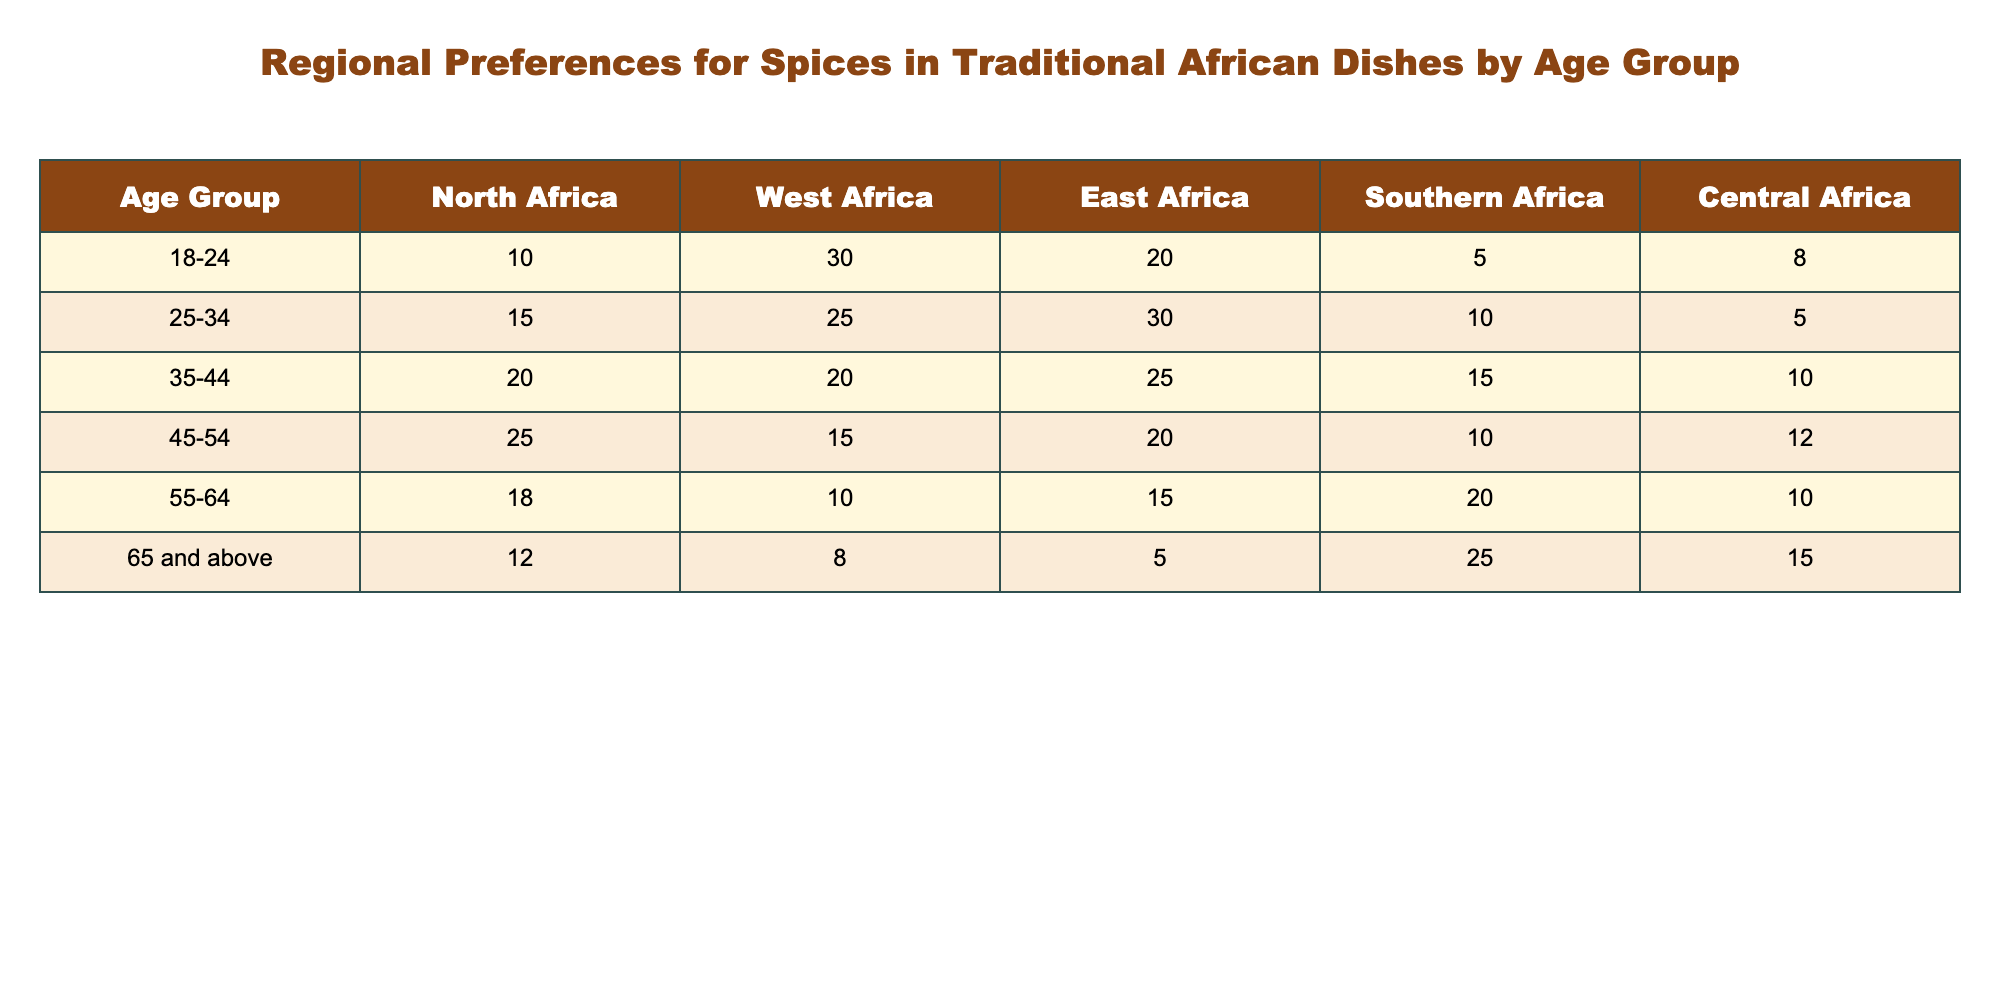What is the highest number of spice preferences in East Africa for any age group? The age group with the highest number of spice preferences in East Africa is 25-34, which shows a preference of 30. Looking at the column for East Africa, I see the following values: 20, 30, 25, 20, 15, and 5. The maximum is clearly 30.
Answer: 30 Which age group shows the least preference for spices in Southern Africa? In Southern Africa, the age group with the least preference is 18-24, which shows a preference of 5. Scanning down the Southern Africa column, the preferences for this age group are 5, 10, 15, 10, 20, and 25. The number 5 is the lowest.
Answer: 5 Is it true that the total preference for spices in Central Africa is greater than in North Africa for age group 45-54? To verify this, we first look at the preferences: Central Africa for 45-54 is 12, while North Africa for the same age group is 25. Since 12 < 25, it is not true that Central Africa's total preference is greater.
Answer: No What is the overall preference for spices in West Africa across all age groups? To find the overall preference for West Africa, I sum all values in that column: 30 + 25 + 20 + 15 + 10 + 8 = 108. Thus, the total preference is the sum of these numbers.
Answer: 108 For the age group 55-64, which region has the highest preference for spices, and what is that value? Reviewing the age group 55-64, the values for each region are: North Africa (18), West Africa (10), East Africa (15), Southern Africa (20), and Central Africa (10). The highest value is in Southern Africa with 20. Therefore, we conclude that Southern Africa has the highest preference.
Answer: Southern Africa, 20 What is the difference in spice preferences between the age group 25-34 in East Africa and that of 45-54 in the same region? For East Africa, the preference for 25-34 is 30, and for 45-54 it is 20. The difference is calculated by subtracting: 30 - 20 = 10. This shows that the younger group has a significantly higher preference.
Answer: 10 Does the preference for spices in North Africa increase or decrease as people age from 18-24 to 65 and above? Inspecting the North Africa preferences by age groups: 10, 15, 20, 25, 18, and 12 shows an increase from 18-24 to 45-54 and then a decrease towards the older age group. Thus, the overall trend is not consistent, since it increases then decreases.
Answer: No What is the average spice preference for all age groups in Southern Africa? To calculate the average, first sum the preferences for Southern Africa: 5 + 10 + 15 + 10 + 20 + 25 = 95. There are six age groups, so the average is 95 / 6, which equals approximately 15.83. Hence, the average spice preference is derived from dividing the total by the number of groups.
Answer: 15.83 